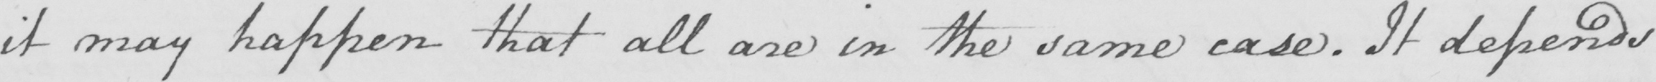What is written in this line of handwriting? it may happen that all are in the same case . It depends 